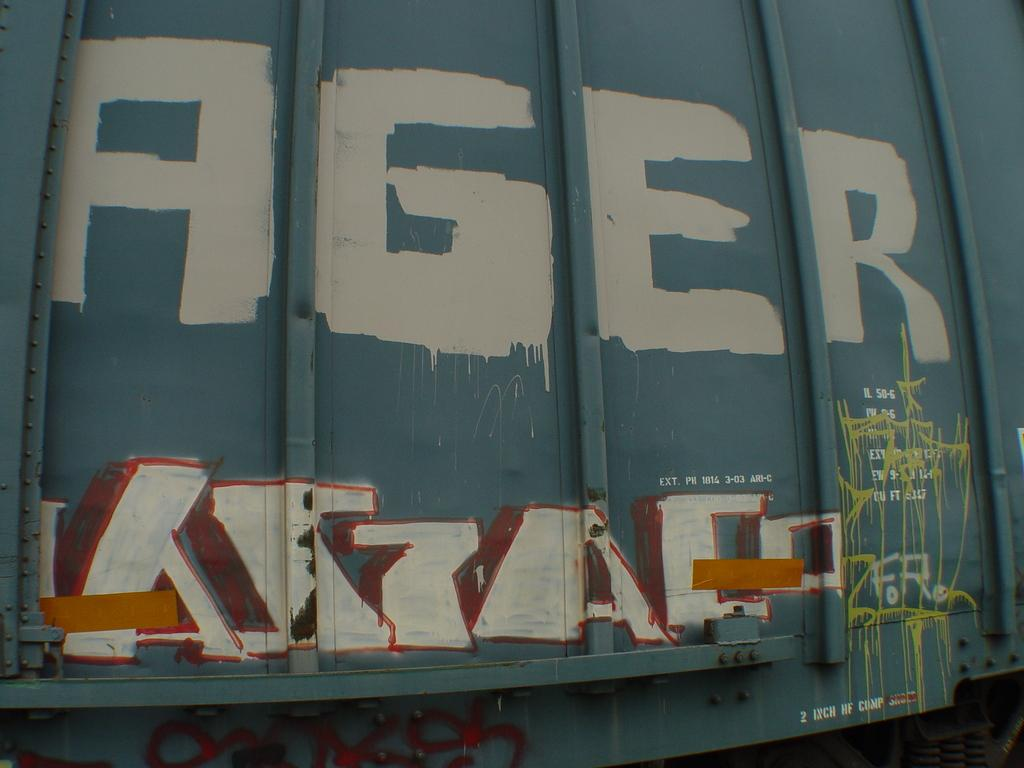What is the main subject of the image? The main subject of the image is a vehicle. What can be seen on the vehicle? There is graffiti on the vehicle. What type of voyage is the toad embarking on in the image? There is no toad or voyage present in the image; it only features a vehicle with graffiti. 